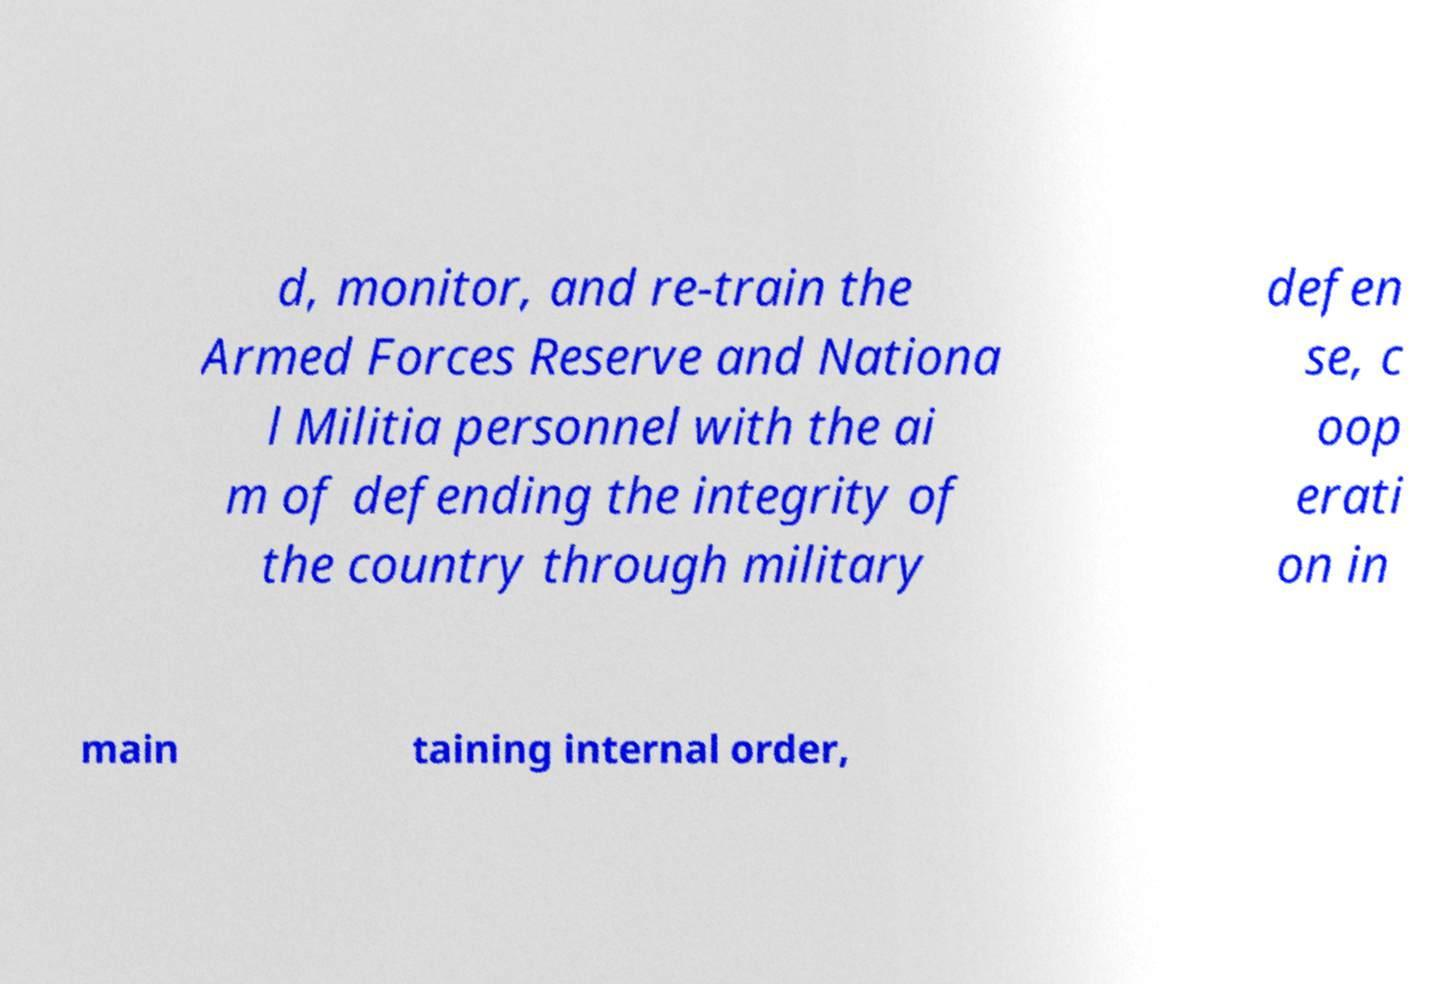Please read and relay the text visible in this image. What does it say? d, monitor, and re-train the Armed Forces Reserve and Nationa l Militia personnel with the ai m of defending the integrity of the country through military defen se, c oop erati on in main taining internal order, 